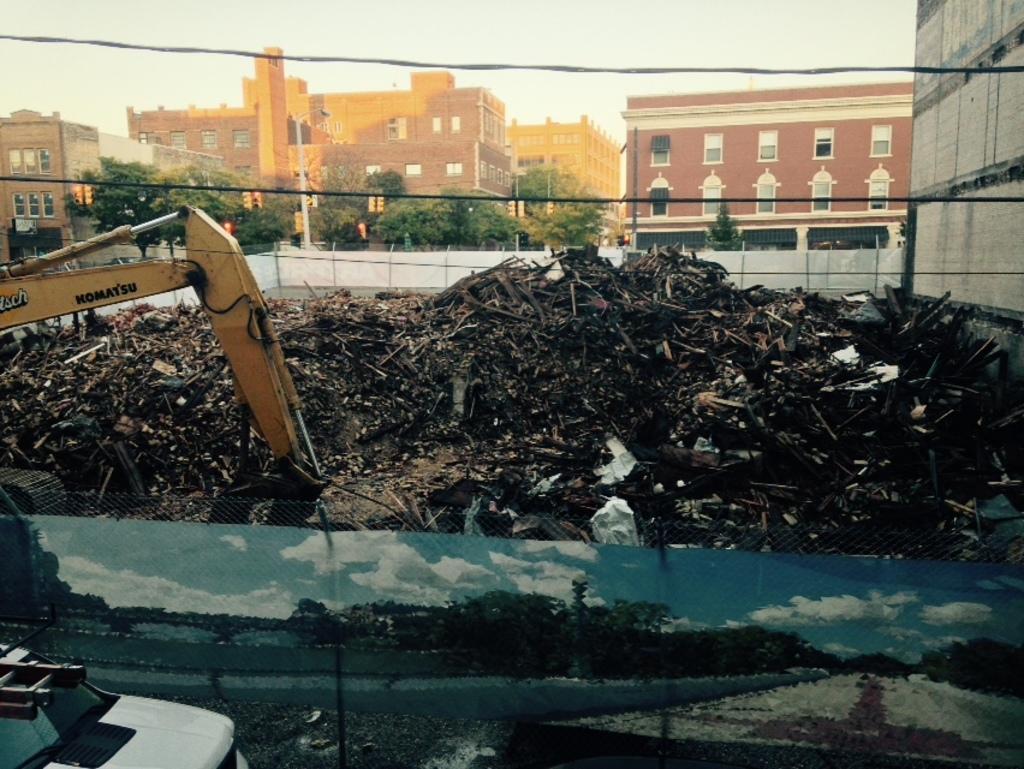How would you summarize this image in a sentence or two? This image is edited and made as a collage. We can see a vehicle, garbage, buildings, trees, poles and sky. And we can see a vehicle, road and trees. 